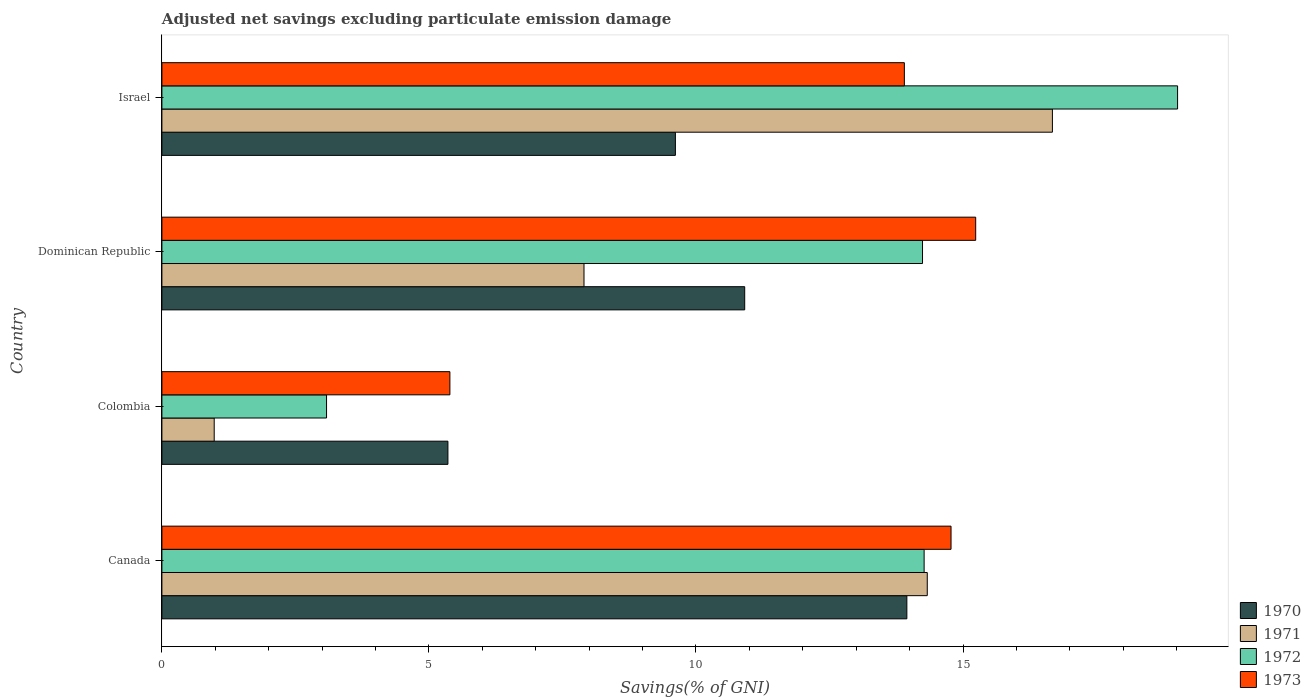How many different coloured bars are there?
Your answer should be very brief. 4. How many groups of bars are there?
Your answer should be very brief. 4. How many bars are there on the 3rd tick from the top?
Offer a very short reply. 4. What is the label of the 4th group of bars from the top?
Provide a succinct answer. Canada. What is the adjusted net savings in 1972 in Israel?
Provide a short and direct response. 19.02. Across all countries, what is the maximum adjusted net savings in 1972?
Your answer should be compact. 19.02. Across all countries, what is the minimum adjusted net savings in 1972?
Your answer should be compact. 3.08. In which country was the adjusted net savings in 1973 maximum?
Offer a terse response. Dominican Republic. In which country was the adjusted net savings in 1971 minimum?
Provide a short and direct response. Colombia. What is the total adjusted net savings in 1972 in the graph?
Make the answer very short. 50.62. What is the difference between the adjusted net savings in 1970 in Canada and that in Dominican Republic?
Offer a very short reply. 3.04. What is the difference between the adjusted net savings in 1971 in Dominican Republic and the adjusted net savings in 1973 in Colombia?
Provide a succinct answer. 2.51. What is the average adjusted net savings in 1973 per country?
Provide a short and direct response. 12.33. What is the difference between the adjusted net savings in 1971 and adjusted net savings in 1972 in Canada?
Your response must be concise. 0.06. In how many countries, is the adjusted net savings in 1972 greater than 6 %?
Offer a very short reply. 3. What is the ratio of the adjusted net savings in 1971 in Canada to that in Israel?
Offer a terse response. 0.86. Is the adjusted net savings in 1970 in Colombia less than that in Israel?
Your answer should be very brief. Yes. What is the difference between the highest and the second highest adjusted net savings in 1972?
Make the answer very short. 4.75. What is the difference between the highest and the lowest adjusted net savings in 1972?
Provide a short and direct response. 15.94. Are all the bars in the graph horizontal?
Your response must be concise. Yes. Are the values on the major ticks of X-axis written in scientific E-notation?
Your answer should be compact. No. Does the graph contain any zero values?
Your response must be concise. No. How many legend labels are there?
Your response must be concise. 4. What is the title of the graph?
Your answer should be compact. Adjusted net savings excluding particulate emission damage. Does "2003" appear as one of the legend labels in the graph?
Provide a short and direct response. No. What is the label or title of the X-axis?
Give a very brief answer. Savings(% of GNI). What is the label or title of the Y-axis?
Keep it short and to the point. Country. What is the Savings(% of GNI) in 1970 in Canada?
Your response must be concise. 13.95. What is the Savings(% of GNI) in 1971 in Canada?
Offer a terse response. 14.33. What is the Savings(% of GNI) of 1972 in Canada?
Provide a succinct answer. 14.27. What is the Savings(% of GNI) in 1973 in Canada?
Keep it short and to the point. 14.78. What is the Savings(% of GNI) in 1970 in Colombia?
Your answer should be very brief. 5.36. What is the Savings(% of GNI) of 1971 in Colombia?
Make the answer very short. 0.98. What is the Savings(% of GNI) in 1972 in Colombia?
Give a very brief answer. 3.08. What is the Savings(% of GNI) of 1973 in Colombia?
Offer a very short reply. 5.39. What is the Savings(% of GNI) of 1970 in Dominican Republic?
Provide a succinct answer. 10.91. What is the Savings(% of GNI) of 1971 in Dominican Republic?
Offer a very short reply. 7.9. What is the Savings(% of GNI) of 1972 in Dominican Republic?
Give a very brief answer. 14.24. What is the Savings(% of GNI) in 1973 in Dominican Republic?
Provide a succinct answer. 15.24. What is the Savings(% of GNI) in 1970 in Israel?
Provide a succinct answer. 9.61. What is the Savings(% of GNI) in 1971 in Israel?
Your answer should be very brief. 16.67. What is the Savings(% of GNI) in 1972 in Israel?
Your answer should be very brief. 19.02. What is the Savings(% of GNI) in 1973 in Israel?
Your answer should be compact. 13.9. Across all countries, what is the maximum Savings(% of GNI) in 1970?
Keep it short and to the point. 13.95. Across all countries, what is the maximum Savings(% of GNI) of 1971?
Offer a terse response. 16.67. Across all countries, what is the maximum Savings(% of GNI) in 1972?
Offer a terse response. 19.02. Across all countries, what is the maximum Savings(% of GNI) in 1973?
Provide a short and direct response. 15.24. Across all countries, what is the minimum Savings(% of GNI) of 1970?
Ensure brevity in your answer.  5.36. Across all countries, what is the minimum Savings(% of GNI) of 1971?
Provide a succinct answer. 0.98. Across all countries, what is the minimum Savings(% of GNI) in 1972?
Keep it short and to the point. 3.08. Across all countries, what is the minimum Savings(% of GNI) in 1973?
Provide a succinct answer. 5.39. What is the total Savings(% of GNI) in 1970 in the graph?
Provide a short and direct response. 39.83. What is the total Savings(% of GNI) of 1971 in the graph?
Ensure brevity in your answer.  39.89. What is the total Savings(% of GNI) of 1972 in the graph?
Offer a terse response. 50.62. What is the total Savings(% of GNI) in 1973 in the graph?
Your answer should be very brief. 49.31. What is the difference between the Savings(% of GNI) in 1970 in Canada and that in Colombia?
Your response must be concise. 8.59. What is the difference between the Savings(% of GNI) of 1971 in Canada and that in Colombia?
Keep it short and to the point. 13.35. What is the difference between the Savings(% of GNI) in 1972 in Canada and that in Colombia?
Keep it short and to the point. 11.19. What is the difference between the Savings(% of GNI) of 1973 in Canada and that in Colombia?
Offer a very short reply. 9.38. What is the difference between the Savings(% of GNI) in 1970 in Canada and that in Dominican Republic?
Ensure brevity in your answer.  3.04. What is the difference between the Savings(% of GNI) in 1971 in Canada and that in Dominican Republic?
Provide a succinct answer. 6.43. What is the difference between the Savings(% of GNI) in 1972 in Canada and that in Dominican Republic?
Make the answer very short. 0.03. What is the difference between the Savings(% of GNI) of 1973 in Canada and that in Dominican Republic?
Provide a short and direct response. -0.46. What is the difference between the Savings(% of GNI) of 1970 in Canada and that in Israel?
Your answer should be very brief. 4.33. What is the difference between the Savings(% of GNI) in 1971 in Canada and that in Israel?
Your answer should be very brief. -2.34. What is the difference between the Savings(% of GNI) in 1972 in Canada and that in Israel?
Keep it short and to the point. -4.75. What is the difference between the Savings(% of GNI) in 1973 in Canada and that in Israel?
Make the answer very short. 0.87. What is the difference between the Savings(% of GNI) in 1970 in Colombia and that in Dominican Republic?
Offer a terse response. -5.56. What is the difference between the Savings(% of GNI) in 1971 in Colombia and that in Dominican Republic?
Provide a succinct answer. -6.92. What is the difference between the Savings(% of GNI) in 1972 in Colombia and that in Dominican Republic?
Your answer should be very brief. -11.16. What is the difference between the Savings(% of GNI) in 1973 in Colombia and that in Dominican Republic?
Ensure brevity in your answer.  -9.85. What is the difference between the Savings(% of GNI) of 1970 in Colombia and that in Israel?
Make the answer very short. -4.26. What is the difference between the Savings(% of GNI) in 1971 in Colombia and that in Israel?
Your answer should be compact. -15.7. What is the difference between the Savings(% of GNI) in 1972 in Colombia and that in Israel?
Provide a succinct answer. -15.94. What is the difference between the Savings(% of GNI) in 1973 in Colombia and that in Israel?
Provide a succinct answer. -8.51. What is the difference between the Savings(% of GNI) of 1970 in Dominican Republic and that in Israel?
Your response must be concise. 1.3. What is the difference between the Savings(% of GNI) of 1971 in Dominican Republic and that in Israel?
Provide a succinct answer. -8.77. What is the difference between the Savings(% of GNI) of 1972 in Dominican Republic and that in Israel?
Keep it short and to the point. -4.78. What is the difference between the Savings(% of GNI) in 1973 in Dominican Republic and that in Israel?
Your answer should be compact. 1.34. What is the difference between the Savings(% of GNI) of 1970 in Canada and the Savings(% of GNI) of 1971 in Colombia?
Provide a short and direct response. 12.97. What is the difference between the Savings(% of GNI) of 1970 in Canada and the Savings(% of GNI) of 1972 in Colombia?
Keep it short and to the point. 10.87. What is the difference between the Savings(% of GNI) of 1970 in Canada and the Savings(% of GNI) of 1973 in Colombia?
Your answer should be very brief. 8.56. What is the difference between the Savings(% of GNI) of 1971 in Canada and the Savings(% of GNI) of 1972 in Colombia?
Make the answer very short. 11.25. What is the difference between the Savings(% of GNI) in 1971 in Canada and the Savings(% of GNI) in 1973 in Colombia?
Your answer should be compact. 8.94. What is the difference between the Savings(% of GNI) of 1972 in Canada and the Savings(% of GNI) of 1973 in Colombia?
Offer a terse response. 8.88. What is the difference between the Savings(% of GNI) of 1970 in Canada and the Savings(% of GNI) of 1971 in Dominican Republic?
Provide a short and direct response. 6.05. What is the difference between the Savings(% of GNI) in 1970 in Canada and the Savings(% of GNI) in 1972 in Dominican Republic?
Provide a short and direct response. -0.29. What is the difference between the Savings(% of GNI) in 1970 in Canada and the Savings(% of GNI) in 1973 in Dominican Republic?
Give a very brief answer. -1.29. What is the difference between the Savings(% of GNI) in 1971 in Canada and the Savings(% of GNI) in 1972 in Dominican Republic?
Offer a terse response. 0.09. What is the difference between the Savings(% of GNI) in 1971 in Canada and the Savings(% of GNI) in 1973 in Dominican Republic?
Keep it short and to the point. -0.91. What is the difference between the Savings(% of GNI) of 1972 in Canada and the Savings(% of GNI) of 1973 in Dominican Republic?
Ensure brevity in your answer.  -0.97. What is the difference between the Savings(% of GNI) in 1970 in Canada and the Savings(% of GNI) in 1971 in Israel?
Offer a very short reply. -2.73. What is the difference between the Savings(% of GNI) in 1970 in Canada and the Savings(% of GNI) in 1972 in Israel?
Provide a short and direct response. -5.07. What is the difference between the Savings(% of GNI) of 1970 in Canada and the Savings(% of GNI) of 1973 in Israel?
Your answer should be compact. 0.05. What is the difference between the Savings(% of GNI) of 1971 in Canada and the Savings(% of GNI) of 1972 in Israel?
Your answer should be compact. -4.69. What is the difference between the Savings(% of GNI) in 1971 in Canada and the Savings(% of GNI) in 1973 in Israel?
Offer a terse response. 0.43. What is the difference between the Savings(% of GNI) in 1972 in Canada and the Savings(% of GNI) in 1973 in Israel?
Your response must be concise. 0.37. What is the difference between the Savings(% of GNI) in 1970 in Colombia and the Savings(% of GNI) in 1971 in Dominican Republic?
Your answer should be compact. -2.55. What is the difference between the Savings(% of GNI) of 1970 in Colombia and the Savings(% of GNI) of 1972 in Dominican Republic?
Offer a very short reply. -8.89. What is the difference between the Savings(% of GNI) of 1970 in Colombia and the Savings(% of GNI) of 1973 in Dominican Republic?
Ensure brevity in your answer.  -9.88. What is the difference between the Savings(% of GNI) of 1971 in Colombia and the Savings(% of GNI) of 1972 in Dominican Republic?
Offer a terse response. -13.26. What is the difference between the Savings(% of GNI) in 1971 in Colombia and the Savings(% of GNI) in 1973 in Dominican Republic?
Your answer should be compact. -14.26. What is the difference between the Savings(% of GNI) of 1972 in Colombia and the Savings(% of GNI) of 1973 in Dominican Republic?
Make the answer very short. -12.15. What is the difference between the Savings(% of GNI) of 1970 in Colombia and the Savings(% of GNI) of 1971 in Israel?
Keep it short and to the point. -11.32. What is the difference between the Savings(% of GNI) of 1970 in Colombia and the Savings(% of GNI) of 1972 in Israel?
Give a very brief answer. -13.66. What is the difference between the Savings(% of GNI) in 1970 in Colombia and the Savings(% of GNI) in 1973 in Israel?
Offer a terse response. -8.55. What is the difference between the Savings(% of GNI) of 1971 in Colombia and the Savings(% of GNI) of 1972 in Israel?
Give a very brief answer. -18.04. What is the difference between the Savings(% of GNI) of 1971 in Colombia and the Savings(% of GNI) of 1973 in Israel?
Offer a terse response. -12.92. What is the difference between the Savings(% of GNI) in 1972 in Colombia and the Savings(% of GNI) in 1973 in Israel?
Keep it short and to the point. -10.82. What is the difference between the Savings(% of GNI) in 1970 in Dominican Republic and the Savings(% of GNI) in 1971 in Israel?
Your response must be concise. -5.76. What is the difference between the Savings(% of GNI) in 1970 in Dominican Republic and the Savings(% of GNI) in 1972 in Israel?
Your answer should be very brief. -8.11. What is the difference between the Savings(% of GNI) in 1970 in Dominican Republic and the Savings(% of GNI) in 1973 in Israel?
Your answer should be compact. -2.99. What is the difference between the Savings(% of GNI) in 1971 in Dominican Republic and the Savings(% of GNI) in 1972 in Israel?
Your response must be concise. -11.11. What is the difference between the Savings(% of GNI) of 1971 in Dominican Republic and the Savings(% of GNI) of 1973 in Israel?
Your answer should be very brief. -6. What is the difference between the Savings(% of GNI) of 1972 in Dominican Republic and the Savings(% of GNI) of 1973 in Israel?
Your response must be concise. 0.34. What is the average Savings(% of GNI) of 1970 per country?
Your answer should be compact. 9.96. What is the average Savings(% of GNI) of 1971 per country?
Give a very brief answer. 9.97. What is the average Savings(% of GNI) in 1972 per country?
Make the answer very short. 12.65. What is the average Savings(% of GNI) of 1973 per country?
Provide a short and direct response. 12.33. What is the difference between the Savings(% of GNI) in 1970 and Savings(% of GNI) in 1971 in Canada?
Give a very brief answer. -0.38. What is the difference between the Savings(% of GNI) of 1970 and Savings(% of GNI) of 1972 in Canada?
Your answer should be compact. -0.32. What is the difference between the Savings(% of GNI) of 1970 and Savings(% of GNI) of 1973 in Canada?
Offer a very short reply. -0.83. What is the difference between the Savings(% of GNI) in 1971 and Savings(% of GNI) in 1972 in Canada?
Your answer should be very brief. 0.06. What is the difference between the Savings(% of GNI) of 1971 and Savings(% of GNI) of 1973 in Canada?
Your answer should be very brief. -0.45. What is the difference between the Savings(% of GNI) of 1972 and Savings(% of GNI) of 1973 in Canada?
Give a very brief answer. -0.5. What is the difference between the Savings(% of GNI) of 1970 and Savings(% of GNI) of 1971 in Colombia?
Offer a terse response. 4.38. What is the difference between the Savings(% of GNI) in 1970 and Savings(% of GNI) in 1972 in Colombia?
Ensure brevity in your answer.  2.27. What is the difference between the Savings(% of GNI) in 1970 and Savings(% of GNI) in 1973 in Colombia?
Your answer should be very brief. -0.04. What is the difference between the Savings(% of GNI) of 1971 and Savings(% of GNI) of 1972 in Colombia?
Your answer should be compact. -2.1. What is the difference between the Savings(% of GNI) of 1971 and Savings(% of GNI) of 1973 in Colombia?
Keep it short and to the point. -4.41. What is the difference between the Savings(% of GNI) of 1972 and Savings(% of GNI) of 1973 in Colombia?
Provide a short and direct response. -2.31. What is the difference between the Savings(% of GNI) of 1970 and Savings(% of GNI) of 1971 in Dominican Republic?
Give a very brief answer. 3.01. What is the difference between the Savings(% of GNI) in 1970 and Savings(% of GNI) in 1972 in Dominican Republic?
Make the answer very short. -3.33. What is the difference between the Savings(% of GNI) of 1970 and Savings(% of GNI) of 1973 in Dominican Republic?
Your response must be concise. -4.33. What is the difference between the Savings(% of GNI) of 1971 and Savings(% of GNI) of 1972 in Dominican Republic?
Offer a terse response. -6.34. What is the difference between the Savings(% of GNI) of 1971 and Savings(% of GNI) of 1973 in Dominican Republic?
Offer a terse response. -7.33. What is the difference between the Savings(% of GNI) in 1972 and Savings(% of GNI) in 1973 in Dominican Republic?
Give a very brief answer. -1. What is the difference between the Savings(% of GNI) in 1970 and Savings(% of GNI) in 1971 in Israel?
Offer a very short reply. -7.06. What is the difference between the Savings(% of GNI) of 1970 and Savings(% of GNI) of 1972 in Israel?
Offer a very short reply. -9.4. What is the difference between the Savings(% of GNI) of 1970 and Savings(% of GNI) of 1973 in Israel?
Make the answer very short. -4.29. What is the difference between the Savings(% of GNI) in 1971 and Savings(% of GNI) in 1972 in Israel?
Your answer should be compact. -2.34. What is the difference between the Savings(% of GNI) in 1971 and Savings(% of GNI) in 1973 in Israel?
Your answer should be compact. 2.77. What is the difference between the Savings(% of GNI) in 1972 and Savings(% of GNI) in 1973 in Israel?
Your response must be concise. 5.12. What is the ratio of the Savings(% of GNI) in 1970 in Canada to that in Colombia?
Provide a succinct answer. 2.6. What is the ratio of the Savings(% of GNI) of 1971 in Canada to that in Colombia?
Your answer should be compact. 14.64. What is the ratio of the Savings(% of GNI) in 1972 in Canada to that in Colombia?
Provide a succinct answer. 4.63. What is the ratio of the Savings(% of GNI) of 1973 in Canada to that in Colombia?
Give a very brief answer. 2.74. What is the ratio of the Savings(% of GNI) of 1970 in Canada to that in Dominican Republic?
Provide a short and direct response. 1.28. What is the ratio of the Savings(% of GNI) in 1971 in Canada to that in Dominican Republic?
Provide a succinct answer. 1.81. What is the ratio of the Savings(% of GNI) of 1972 in Canada to that in Dominican Republic?
Provide a short and direct response. 1. What is the ratio of the Savings(% of GNI) of 1973 in Canada to that in Dominican Republic?
Keep it short and to the point. 0.97. What is the ratio of the Savings(% of GNI) of 1970 in Canada to that in Israel?
Provide a short and direct response. 1.45. What is the ratio of the Savings(% of GNI) in 1971 in Canada to that in Israel?
Ensure brevity in your answer.  0.86. What is the ratio of the Savings(% of GNI) of 1972 in Canada to that in Israel?
Provide a short and direct response. 0.75. What is the ratio of the Savings(% of GNI) in 1973 in Canada to that in Israel?
Your answer should be very brief. 1.06. What is the ratio of the Savings(% of GNI) in 1970 in Colombia to that in Dominican Republic?
Your answer should be compact. 0.49. What is the ratio of the Savings(% of GNI) in 1971 in Colombia to that in Dominican Republic?
Ensure brevity in your answer.  0.12. What is the ratio of the Savings(% of GNI) of 1972 in Colombia to that in Dominican Republic?
Ensure brevity in your answer.  0.22. What is the ratio of the Savings(% of GNI) of 1973 in Colombia to that in Dominican Republic?
Your answer should be compact. 0.35. What is the ratio of the Savings(% of GNI) in 1970 in Colombia to that in Israel?
Your answer should be very brief. 0.56. What is the ratio of the Savings(% of GNI) of 1971 in Colombia to that in Israel?
Your response must be concise. 0.06. What is the ratio of the Savings(% of GNI) in 1972 in Colombia to that in Israel?
Give a very brief answer. 0.16. What is the ratio of the Savings(% of GNI) in 1973 in Colombia to that in Israel?
Keep it short and to the point. 0.39. What is the ratio of the Savings(% of GNI) in 1970 in Dominican Republic to that in Israel?
Make the answer very short. 1.14. What is the ratio of the Savings(% of GNI) of 1971 in Dominican Republic to that in Israel?
Your answer should be very brief. 0.47. What is the ratio of the Savings(% of GNI) in 1972 in Dominican Republic to that in Israel?
Your answer should be compact. 0.75. What is the ratio of the Savings(% of GNI) in 1973 in Dominican Republic to that in Israel?
Your answer should be compact. 1.1. What is the difference between the highest and the second highest Savings(% of GNI) in 1970?
Keep it short and to the point. 3.04. What is the difference between the highest and the second highest Savings(% of GNI) of 1971?
Provide a succinct answer. 2.34. What is the difference between the highest and the second highest Savings(% of GNI) of 1972?
Ensure brevity in your answer.  4.75. What is the difference between the highest and the second highest Savings(% of GNI) of 1973?
Offer a terse response. 0.46. What is the difference between the highest and the lowest Savings(% of GNI) of 1970?
Give a very brief answer. 8.59. What is the difference between the highest and the lowest Savings(% of GNI) in 1971?
Keep it short and to the point. 15.7. What is the difference between the highest and the lowest Savings(% of GNI) of 1972?
Ensure brevity in your answer.  15.94. What is the difference between the highest and the lowest Savings(% of GNI) in 1973?
Keep it short and to the point. 9.85. 